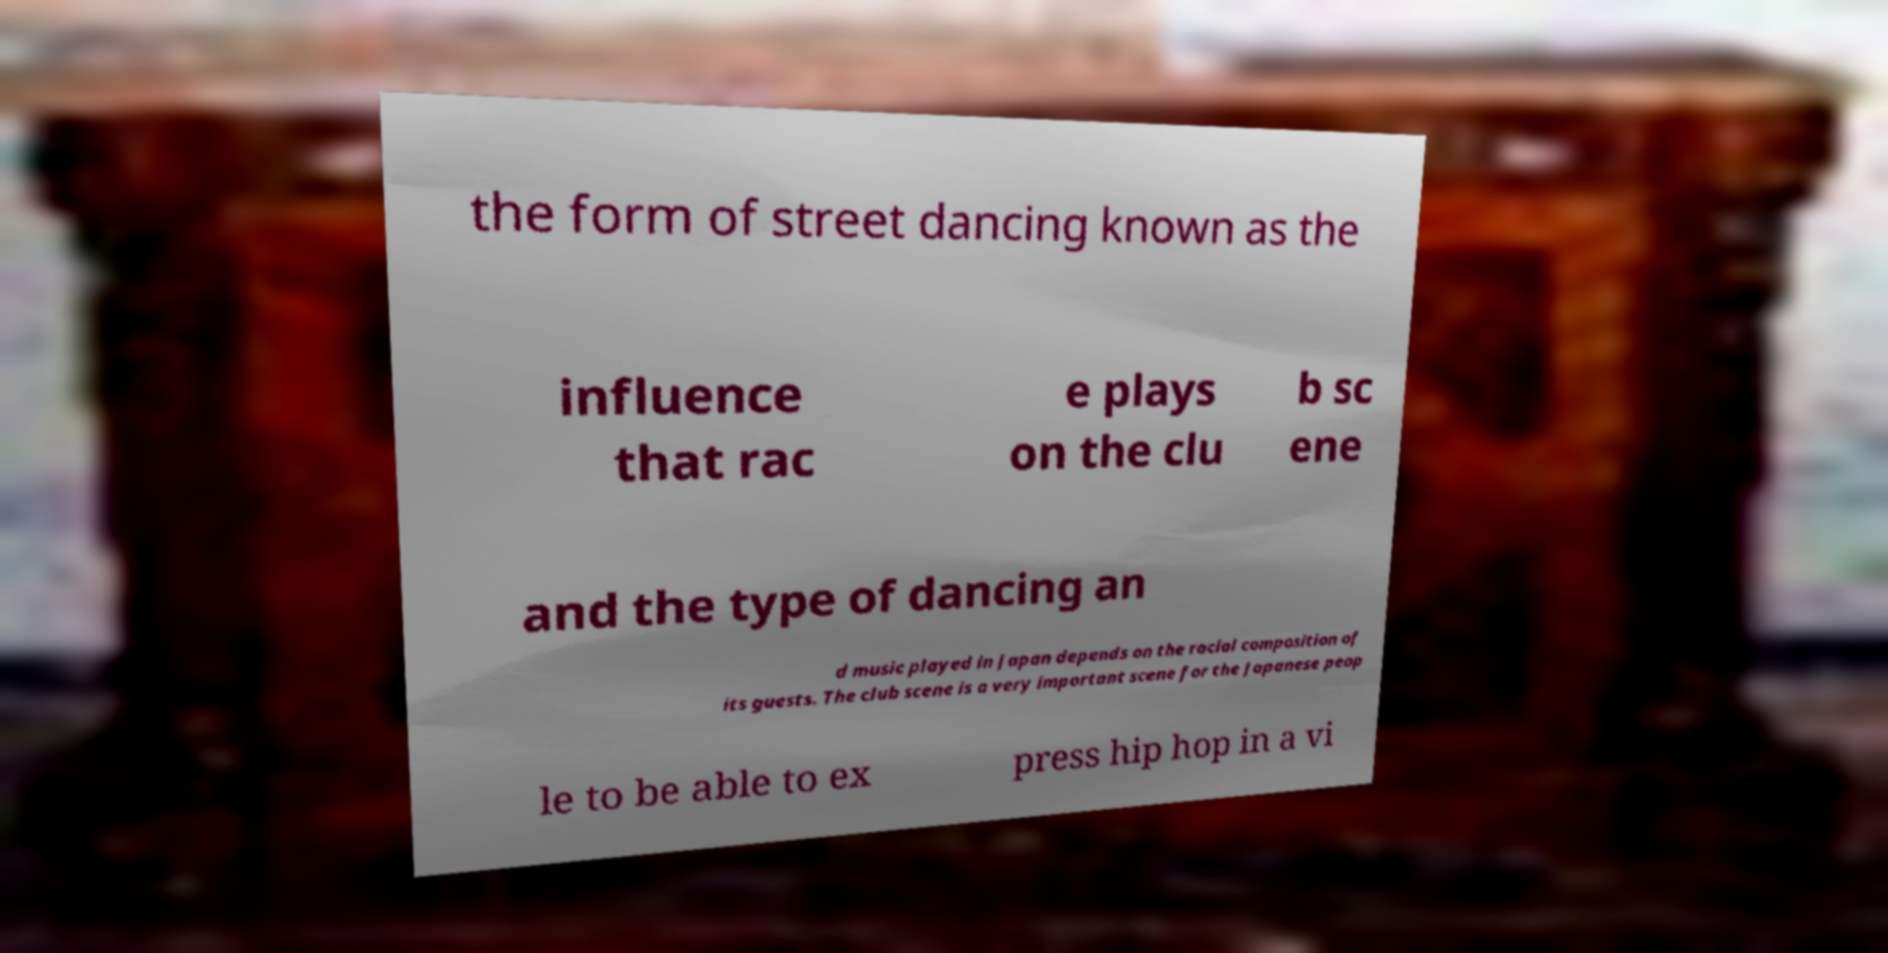Could you extract and type out the text from this image? the form of street dancing known as the influence that rac e plays on the clu b sc ene and the type of dancing an d music played in Japan depends on the racial composition of its guests. The club scene is a very important scene for the Japanese peop le to be able to ex press hip hop in a vi 